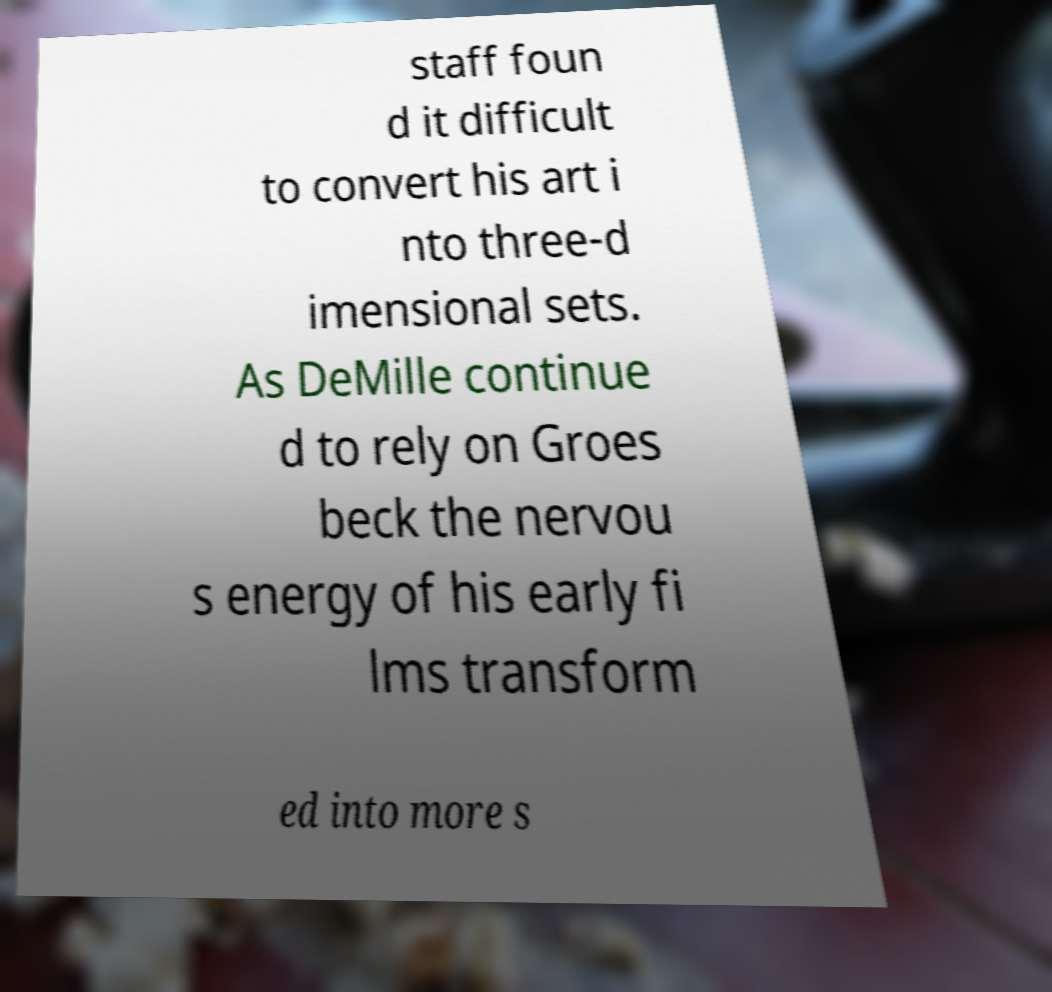What messages or text are displayed in this image? I need them in a readable, typed format. staff foun d it difficult to convert his art i nto three-d imensional sets. As DeMille continue d to rely on Groes beck the nervou s energy of his early fi lms transform ed into more s 